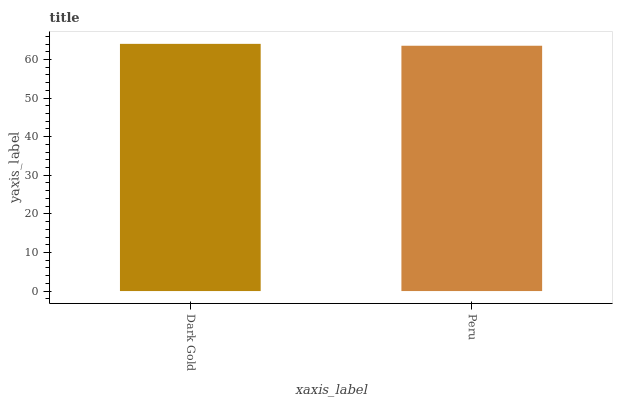Is Peru the minimum?
Answer yes or no. Yes. Is Dark Gold the maximum?
Answer yes or no. Yes. Is Peru the maximum?
Answer yes or no. No. Is Dark Gold greater than Peru?
Answer yes or no. Yes. Is Peru less than Dark Gold?
Answer yes or no. Yes. Is Peru greater than Dark Gold?
Answer yes or no. No. Is Dark Gold less than Peru?
Answer yes or no. No. Is Dark Gold the high median?
Answer yes or no. Yes. Is Peru the low median?
Answer yes or no. Yes. Is Peru the high median?
Answer yes or no. No. Is Dark Gold the low median?
Answer yes or no. No. 